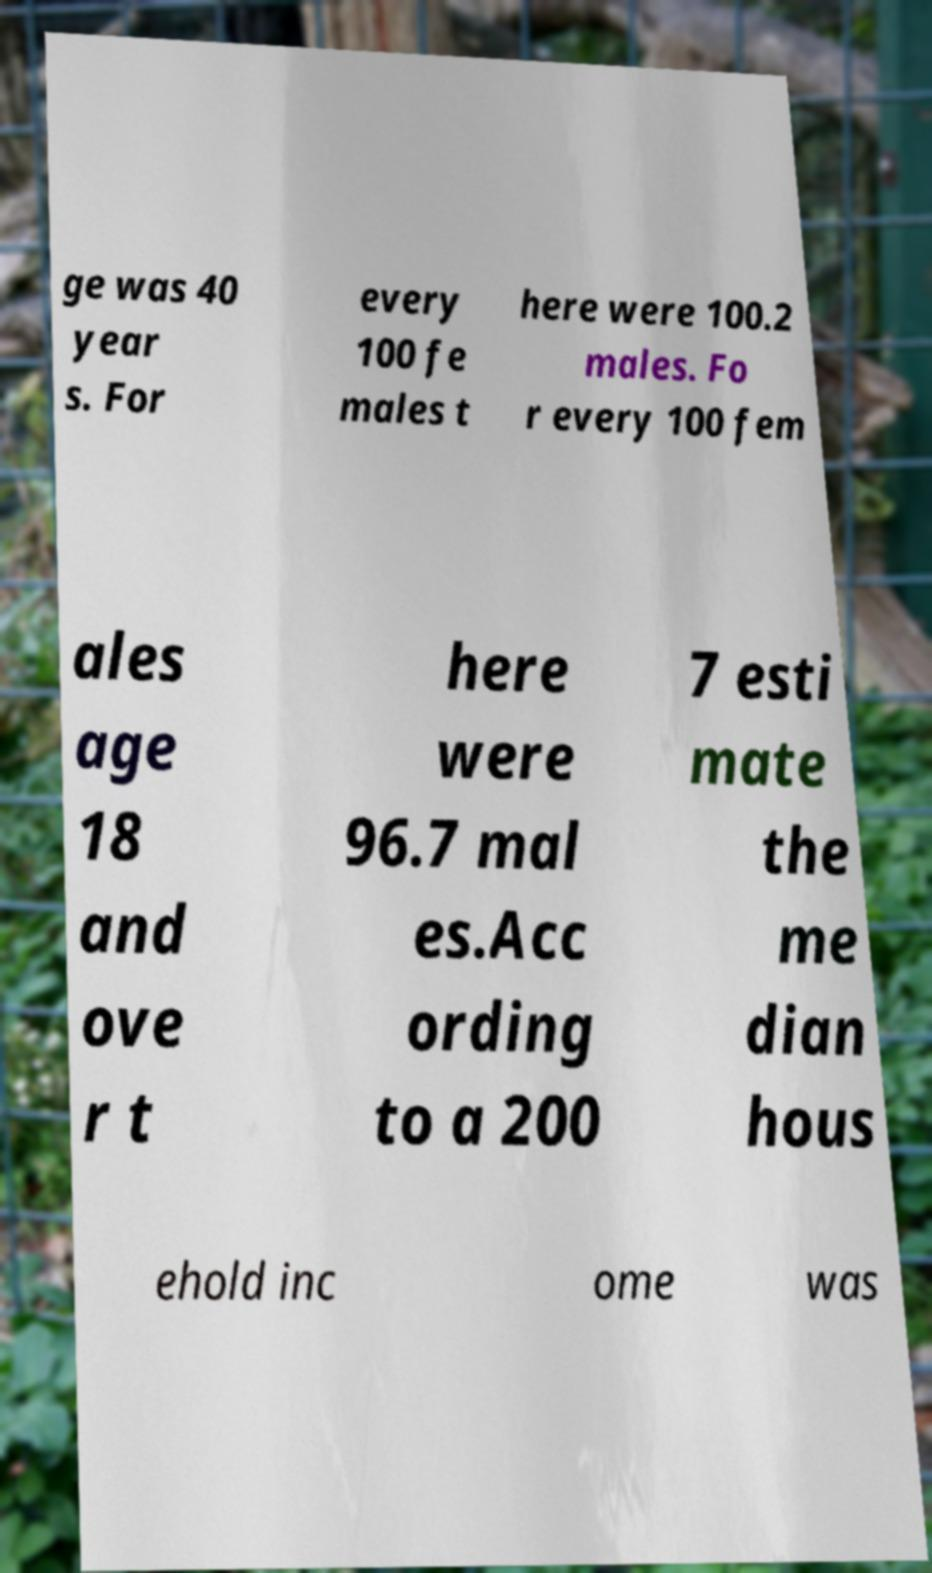There's text embedded in this image that I need extracted. Can you transcribe it verbatim? ge was 40 year s. For every 100 fe males t here were 100.2 males. Fo r every 100 fem ales age 18 and ove r t here were 96.7 mal es.Acc ording to a 200 7 esti mate the me dian hous ehold inc ome was 